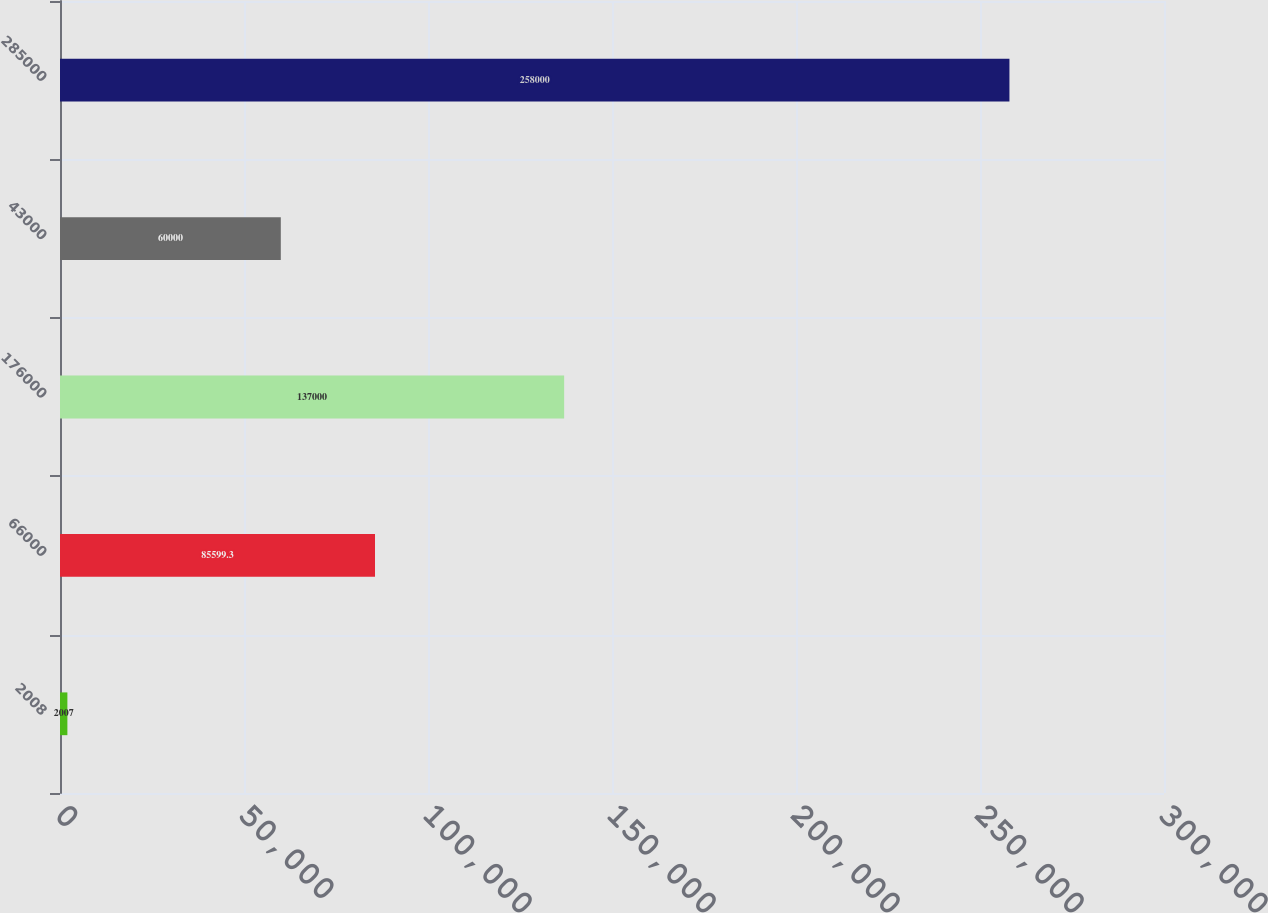<chart> <loc_0><loc_0><loc_500><loc_500><bar_chart><fcel>2008<fcel>66000<fcel>176000<fcel>43000<fcel>285000<nl><fcel>2007<fcel>85599.3<fcel>137000<fcel>60000<fcel>258000<nl></chart> 